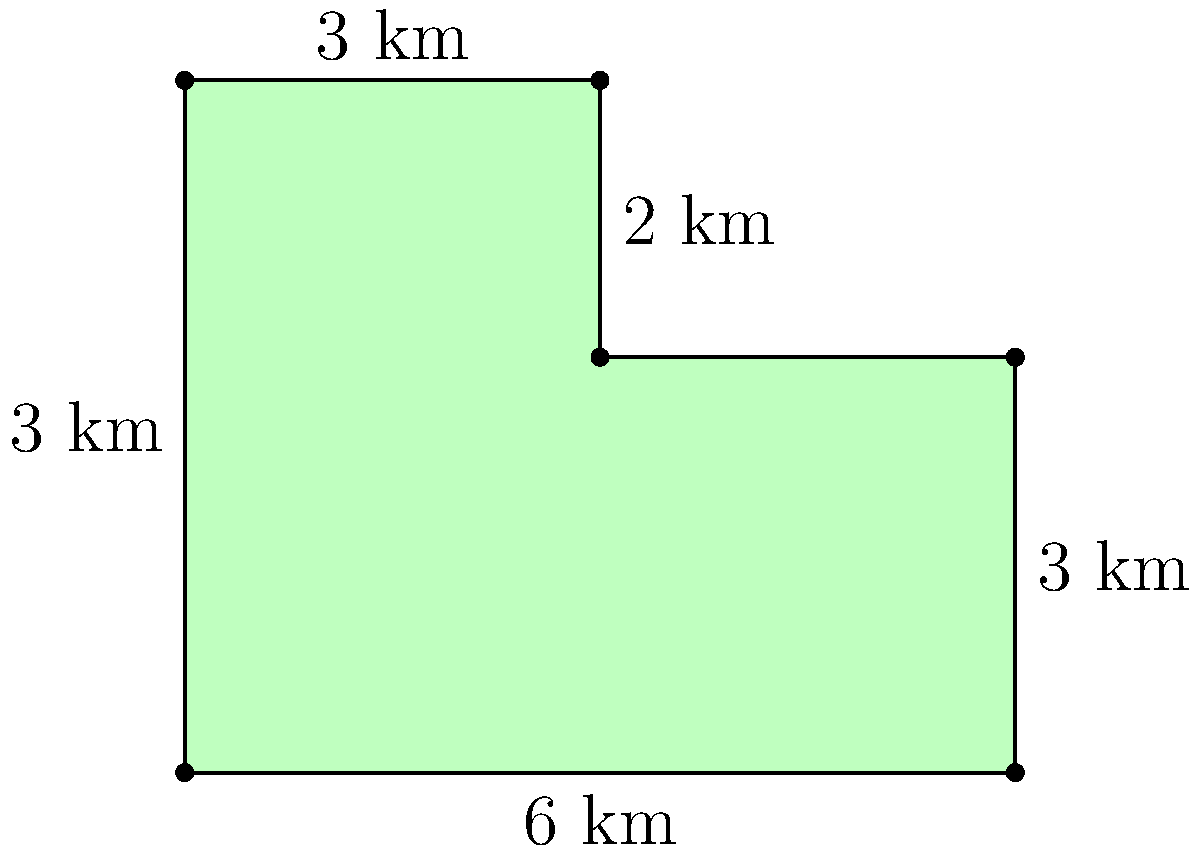A wildlife preserve has an irregular shape as shown in the diagram. The preserve can be divided into a rectangle and a smaller rectangle on top. Given the measurements provided, calculate the total area of the wildlife preserve in square kilometers. To calculate the area of this irregular-shaped wildlife habitat, we can break it down into two rectangles:

1. Larger rectangle (bottom):
   Width = $6$ km
   Height = $3$ km
   Area of larger rectangle = $6 \times 3 = 18$ sq km

2. Smaller rectangle (top):
   Width = $3$ km
   Height = $2$ km (5 km - 3 km)
   Area of smaller rectangle = $3 \times 2 = 6$ sq km

3. Total area:
   Total area = Area of larger rectangle + Area of smaller rectangle
               = $18 + 6 = 24$ sq km

Therefore, the total area of the wildlife preserve is 24 square kilometers.
Answer: 24 sq km 